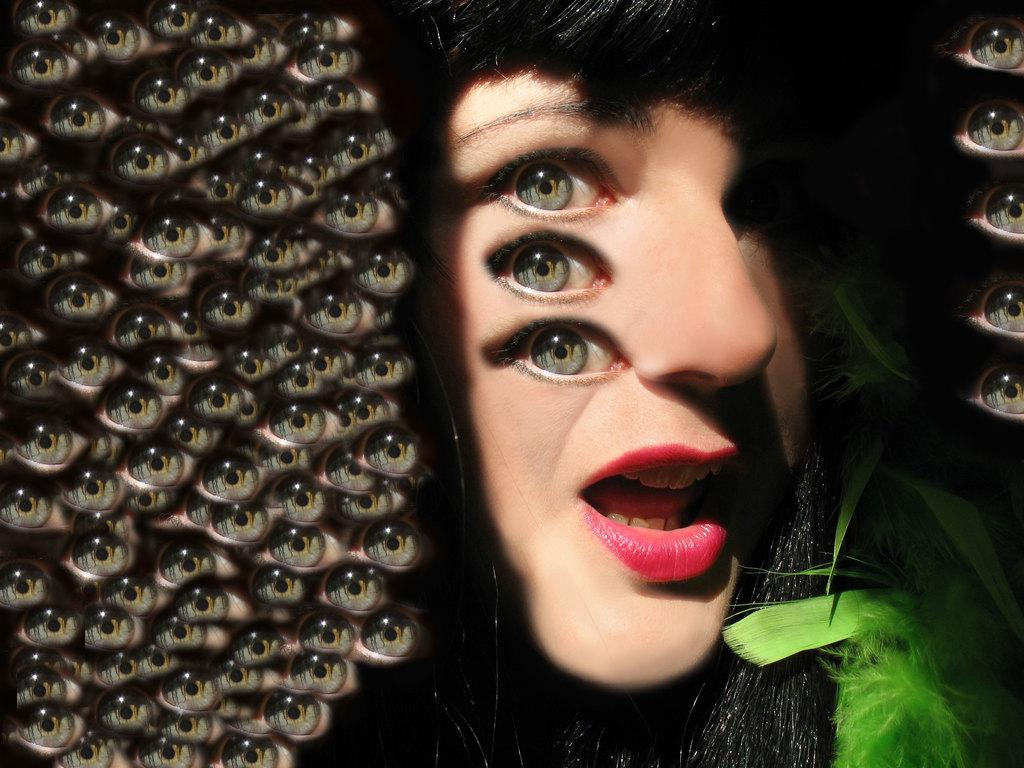What can be said about the nature of the image? The image is edited. What is one specific feature that can be observed in the image? There are eyes in the image. Can you describe the main subject of the image? There is a lady in the image. What is the existence of the fifth gate in the image? There is no mention of a gate, let alone a fifth gate, in the provided facts about the image. 